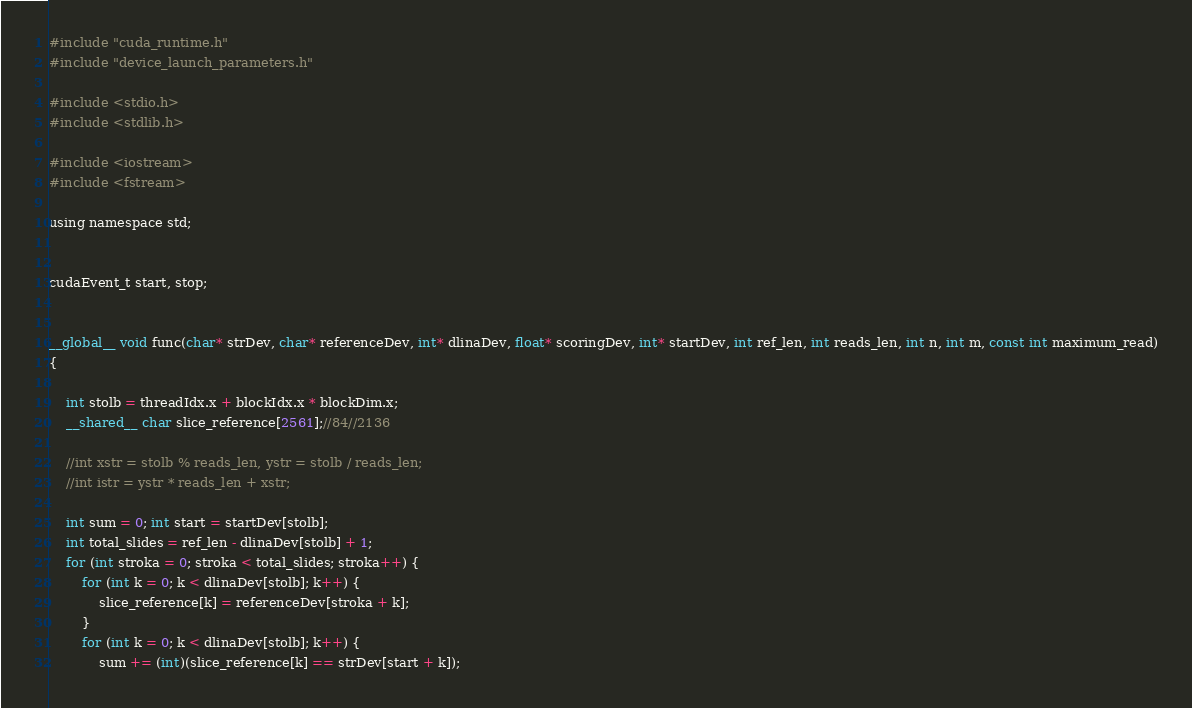<code> <loc_0><loc_0><loc_500><loc_500><_Cuda_>
#include "cuda_runtime.h"
#include "device_launch_parameters.h"

#include <stdio.h>
#include <stdlib.h>

#include <iostream>
#include <fstream>

using namespace std;


cudaEvent_t start, stop;


__global__ void func(char* strDev, char* referenceDev, int* dlinaDev, float* scoringDev, int* startDev, int ref_len, int reads_len, int n, int m, const int maximum_read)
{

	int stolb = threadIdx.x + blockIdx.x * blockDim.x;
	__shared__ char slice_reference[2561];//84//2136

	//int xstr = stolb % reads_len, ystr = stolb / reads_len;
	//int istr = ystr * reads_len + xstr;

	int sum = 0; int start = startDev[stolb];
	int total_slides = ref_len - dlinaDev[stolb] + 1;
	for (int stroka = 0; stroka < total_slides; stroka++) {
		for (int k = 0; k < dlinaDev[stolb]; k++) {
			slice_reference[k] = referenceDev[stroka + k];
		}
		for (int k = 0; k < dlinaDev[stolb]; k++) {
			sum += (int)(slice_reference[k] == strDev[start + k]);</code> 